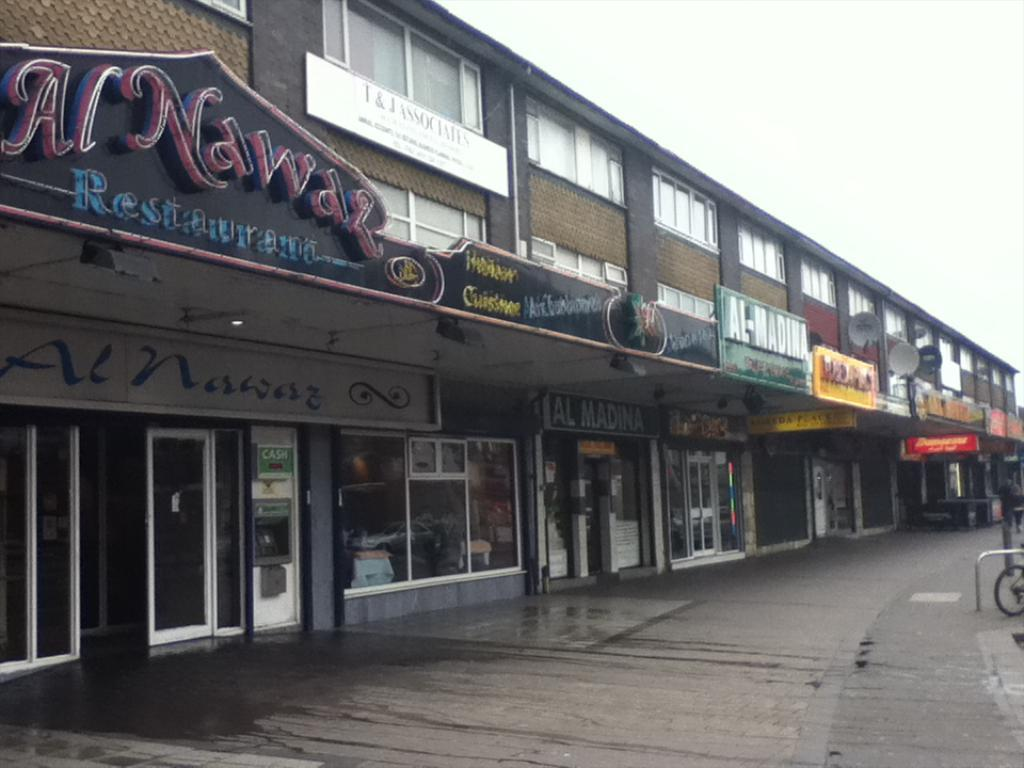What is the main feature of the image? The center of the image contains the sky. What type of structure can be seen in the image? There is a building in the image. What is a notable feature of the building? The building has windows. What type of signage or information is present in the image? There are boards with text in the image. Are there any other objects or features in the image? Yes, there are a few other objects in the image. Can you tell me how many pigs are visible in the image? There are no pigs present in the image. What type of print can be seen on the building's facade? There is no print visible on the building's facade in the image. 